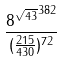Convert formula to latex. <formula><loc_0><loc_0><loc_500><loc_500>\frac { { 8 ^ { \sqrt { 4 3 } } } ^ { 3 8 2 } } { ( \frac { 2 1 5 } { 4 3 0 } ) ^ { 7 2 } }</formula> 